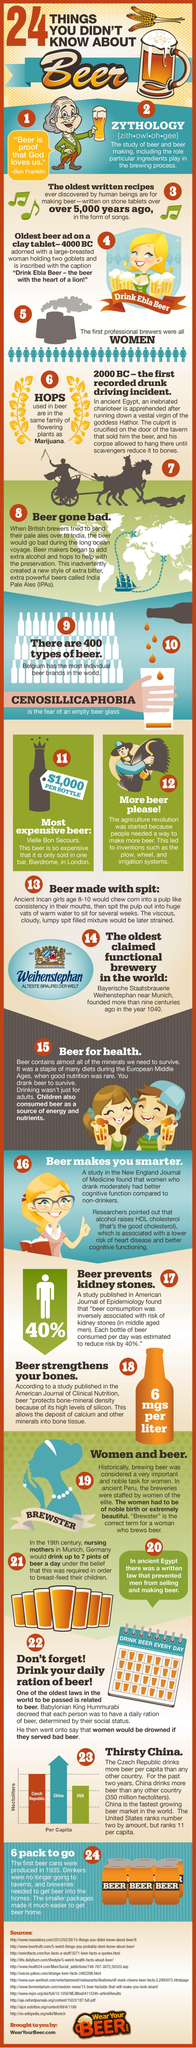Specify some key components in this picture. The plant used to make beer is hops. It was believed in Munich, Germany, that drinking beer could aid in breastfeeding. A woman who drinks beer is referred to as Brewster. The study of beer is known as zythology. 